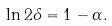<formula> <loc_0><loc_0><loc_500><loc_500>\ln 2 \delta = 1 - \alpha .</formula> 